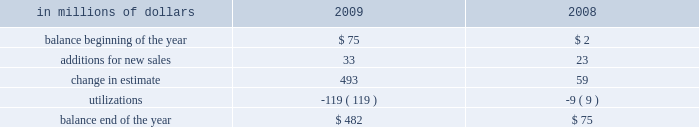Citigroup 2019s repurchases are primarily from government sponsored entities .
The specific representations and warranties made by the company depend on the nature of the transaction and the requirements of the buyer .
Market conditions and credit-ratings agency requirements may also affect representations and warranties and the other provisions the company may agree to in loan sales .
In the event of a breach of the representations and warranties , the company may be required to either repurchase the mortgage loans ( generally at unpaid principal balance plus accrued interest ) with the identified defects or indemnify ( 201cmake-whole 201d ) the investor or insurer .
The company has recorded a repurchase reserve that is included in other liabilities in the consolidated balance sheet .
In the case of a repurchase , the company will bear any subsequent credit loss on the mortgage loans .
The company 2019s representations and warranties are generally not subject to stated limits in amount or time of coverage .
However , contractual liability arises only when the representations and warranties are breached and generally only when a loss results from the breach .
In the case of a repurchase , the loan is typically considered a credit- impaired loan and accounted for under sop 03-3 , 201caccounting for certain loans and debt securities , acquired in a transfer 201d ( now incorporated into asc 310-30 , receivables 2014loans and debt securities acquired with deteriorated credit quality ) .
These repurchases have not had a material impact on nonperforming loan statistics , because credit-impaired purchased sop 03-3 loans are not included in nonaccrual loans .
The company estimates its exposure to losses from its obligation to repurchase previously sold loans based on the probability of repurchase or make-whole and an estimated loss given repurchase or make-whole .
This estimate is calculated separately by sales vintage ( i.e. , the year the loans were sold ) based on a combination of historical trends and forecasted repurchases and losses considering the : ( 1 ) trends in requests by investors for loan documentation packages to be reviewed ; ( 2 ) trends in recent repurchases and make-wholes ; ( 3 ) historical percentage of claims made as a percentage of loan documentation package requests ; ( 4 ) success rate in appealing claims ; ( 5 ) inventory of unresolved claims ; and ( 6 ) estimated loss given repurchase or make-whole , including the loss of principal , accrued interest , and foreclosure costs .
The company does not change its estimation methodology by counterparty , but the historical experience and trends are considered when evaluating the overall reserve .
The request for loan documentation packages is an early indicator of a potential claim .
During 2009 , loan documentation package requests and the level of outstanding claims increased .
In addition , our loss severity estimates increased during 2009 due to the impact of macroeconomic factors and recent experience .
These factors contributed to a $ 493 million change in estimate for this reserve in 2009 .
As indicated above , the repurchase reserve is calculated by sales vintage .
The majority of the repurchases in 2009 were from the 2006 and 2007 sales vintages , which also represent the vintages with the largest loss- given-repurchase .
An insignificant percentage of 2009 repurchases were from vintages prior to 2006 , and this is expected to decrease , because those vintages are later in the credit cycle .
Although early in the credit cycle , the company has experienced improved repurchase and loss-given-repurchase statistics from the 2008 and 2009 vintages .
In the case of a repurchase of a credit-impaired sop 03-3 loan ( now incorporated into asc 310-30 ) , the difference between the loan 2019s fair value and unpaid principal balance at the time of the repurchase is recorded as a utilization of the repurchase reserve .
Payments to make the investor whole are also treated as utilizations and charged directly against the reserve .
The provision for estimated probable losses arising from loan sales is recorded as an adjustment to the gain on sale , which is included in other revenue in the consolidated statement of income .
A liability for representations and warranties is estimated when the company sells loans and is updated quarterly .
Any subsequent adjustment to the provision is recorded in other revenue in the consolidated statement of income .
The activity in the repurchase reserve for the years ended december 31 , 2009 and 2008 is as follows: .
Goodwill goodwill represents an acquired company 2019s acquisition cost over the fair value of net tangible and intangible assets acquired .
Goodwill is subject to annual impairment tests , whereby goodwill is allocated to the company 2019s reporting units and an impairment is deemed to exist if the carrying value of a reporting unit exceeds its estimated fair value .
Furthermore , on any business dispositions , goodwill is allocated to the business disposed of based on the ratio of the fair value of the business disposed of to the fair value of the reporting unit .
Intangible assets intangible assets 2014including core deposit intangibles , present value of future profits , purchased credit card relationships , other customer relationships , and other intangible assets , but excluding msrs 2014are amortized over their estimated useful lives .
Intangible assets deemed to have indefinite useful lives , primarily certain asset management contracts and trade names , are not amortized and are subject to annual impairment tests .
An impairment exists if the carrying value of the indefinite-lived intangible asset exceeds its fair value .
For other intangible assets subject to amortization , an impairment is recognized if the carrying amount is not recoverable and exceeds the fair value of the intangible asset .
Other assets and other liabilities other assets include , among other items , loans held-for-sale , deferred tax assets , equity-method investments , interest and fees receivable , premises and equipment , end-user derivatives in a net receivable position , repossessed assets , and other receivables. .
What was the net change in the repurchase reserve between 2008 and 2009 , in millions? 
Computations: (482 - 75)
Answer: 407.0. Citigroup 2019s repurchases are primarily from government sponsored entities .
The specific representations and warranties made by the company depend on the nature of the transaction and the requirements of the buyer .
Market conditions and credit-ratings agency requirements may also affect representations and warranties and the other provisions the company may agree to in loan sales .
In the event of a breach of the representations and warranties , the company may be required to either repurchase the mortgage loans ( generally at unpaid principal balance plus accrued interest ) with the identified defects or indemnify ( 201cmake-whole 201d ) the investor or insurer .
The company has recorded a repurchase reserve that is included in other liabilities in the consolidated balance sheet .
In the case of a repurchase , the company will bear any subsequent credit loss on the mortgage loans .
The company 2019s representations and warranties are generally not subject to stated limits in amount or time of coverage .
However , contractual liability arises only when the representations and warranties are breached and generally only when a loss results from the breach .
In the case of a repurchase , the loan is typically considered a credit- impaired loan and accounted for under sop 03-3 , 201caccounting for certain loans and debt securities , acquired in a transfer 201d ( now incorporated into asc 310-30 , receivables 2014loans and debt securities acquired with deteriorated credit quality ) .
These repurchases have not had a material impact on nonperforming loan statistics , because credit-impaired purchased sop 03-3 loans are not included in nonaccrual loans .
The company estimates its exposure to losses from its obligation to repurchase previously sold loans based on the probability of repurchase or make-whole and an estimated loss given repurchase or make-whole .
This estimate is calculated separately by sales vintage ( i.e. , the year the loans were sold ) based on a combination of historical trends and forecasted repurchases and losses considering the : ( 1 ) trends in requests by investors for loan documentation packages to be reviewed ; ( 2 ) trends in recent repurchases and make-wholes ; ( 3 ) historical percentage of claims made as a percentage of loan documentation package requests ; ( 4 ) success rate in appealing claims ; ( 5 ) inventory of unresolved claims ; and ( 6 ) estimated loss given repurchase or make-whole , including the loss of principal , accrued interest , and foreclosure costs .
The company does not change its estimation methodology by counterparty , but the historical experience and trends are considered when evaluating the overall reserve .
The request for loan documentation packages is an early indicator of a potential claim .
During 2009 , loan documentation package requests and the level of outstanding claims increased .
In addition , our loss severity estimates increased during 2009 due to the impact of macroeconomic factors and recent experience .
These factors contributed to a $ 493 million change in estimate for this reserve in 2009 .
As indicated above , the repurchase reserve is calculated by sales vintage .
The majority of the repurchases in 2009 were from the 2006 and 2007 sales vintages , which also represent the vintages with the largest loss- given-repurchase .
An insignificant percentage of 2009 repurchases were from vintages prior to 2006 , and this is expected to decrease , because those vintages are later in the credit cycle .
Although early in the credit cycle , the company has experienced improved repurchase and loss-given-repurchase statistics from the 2008 and 2009 vintages .
In the case of a repurchase of a credit-impaired sop 03-3 loan ( now incorporated into asc 310-30 ) , the difference between the loan 2019s fair value and unpaid principal balance at the time of the repurchase is recorded as a utilization of the repurchase reserve .
Payments to make the investor whole are also treated as utilizations and charged directly against the reserve .
The provision for estimated probable losses arising from loan sales is recorded as an adjustment to the gain on sale , which is included in other revenue in the consolidated statement of income .
A liability for representations and warranties is estimated when the company sells loans and is updated quarterly .
Any subsequent adjustment to the provision is recorded in other revenue in the consolidated statement of income .
The activity in the repurchase reserve for the years ended december 31 , 2009 and 2008 is as follows: .
Goodwill goodwill represents an acquired company 2019s acquisition cost over the fair value of net tangible and intangible assets acquired .
Goodwill is subject to annual impairment tests , whereby goodwill is allocated to the company 2019s reporting units and an impairment is deemed to exist if the carrying value of a reporting unit exceeds its estimated fair value .
Furthermore , on any business dispositions , goodwill is allocated to the business disposed of based on the ratio of the fair value of the business disposed of to the fair value of the reporting unit .
Intangible assets intangible assets 2014including core deposit intangibles , present value of future profits , purchased credit card relationships , other customer relationships , and other intangible assets , but excluding msrs 2014are amortized over their estimated useful lives .
Intangible assets deemed to have indefinite useful lives , primarily certain asset management contracts and trade names , are not amortized and are subject to annual impairment tests .
An impairment exists if the carrying value of the indefinite-lived intangible asset exceeds its fair value .
For other intangible assets subject to amortization , an impairment is recognized if the carrying amount is not recoverable and exceeds the fair value of the intangible asset .
Other assets and other liabilities other assets include , among other items , loans held-for-sale , deferred tax assets , equity-method investments , interest and fees receivable , premises and equipment , end-user derivatives in a net receivable position , repossessed assets , and other receivables. .
What was the ratio of the change in estimate for 2009 to 2008? 
Rationale: the ratio of the the change in estimate reserve was $ 8.35 to $ 1 for 2009 compared to 2008
Computations: (493 / 59)
Answer: 8.35593. Citigroup 2019s repurchases are primarily from government sponsored entities .
The specific representations and warranties made by the company depend on the nature of the transaction and the requirements of the buyer .
Market conditions and credit-ratings agency requirements may also affect representations and warranties and the other provisions the company may agree to in loan sales .
In the event of a breach of the representations and warranties , the company may be required to either repurchase the mortgage loans ( generally at unpaid principal balance plus accrued interest ) with the identified defects or indemnify ( 201cmake-whole 201d ) the investor or insurer .
The company has recorded a repurchase reserve that is included in other liabilities in the consolidated balance sheet .
In the case of a repurchase , the company will bear any subsequent credit loss on the mortgage loans .
The company 2019s representations and warranties are generally not subject to stated limits in amount or time of coverage .
However , contractual liability arises only when the representations and warranties are breached and generally only when a loss results from the breach .
In the case of a repurchase , the loan is typically considered a credit- impaired loan and accounted for under sop 03-3 , 201caccounting for certain loans and debt securities , acquired in a transfer 201d ( now incorporated into asc 310-30 , receivables 2014loans and debt securities acquired with deteriorated credit quality ) .
These repurchases have not had a material impact on nonperforming loan statistics , because credit-impaired purchased sop 03-3 loans are not included in nonaccrual loans .
The company estimates its exposure to losses from its obligation to repurchase previously sold loans based on the probability of repurchase or make-whole and an estimated loss given repurchase or make-whole .
This estimate is calculated separately by sales vintage ( i.e. , the year the loans were sold ) based on a combination of historical trends and forecasted repurchases and losses considering the : ( 1 ) trends in requests by investors for loan documentation packages to be reviewed ; ( 2 ) trends in recent repurchases and make-wholes ; ( 3 ) historical percentage of claims made as a percentage of loan documentation package requests ; ( 4 ) success rate in appealing claims ; ( 5 ) inventory of unresolved claims ; and ( 6 ) estimated loss given repurchase or make-whole , including the loss of principal , accrued interest , and foreclosure costs .
The company does not change its estimation methodology by counterparty , but the historical experience and trends are considered when evaluating the overall reserve .
The request for loan documentation packages is an early indicator of a potential claim .
During 2009 , loan documentation package requests and the level of outstanding claims increased .
In addition , our loss severity estimates increased during 2009 due to the impact of macroeconomic factors and recent experience .
These factors contributed to a $ 493 million change in estimate for this reserve in 2009 .
As indicated above , the repurchase reserve is calculated by sales vintage .
The majority of the repurchases in 2009 were from the 2006 and 2007 sales vintages , which also represent the vintages with the largest loss- given-repurchase .
An insignificant percentage of 2009 repurchases were from vintages prior to 2006 , and this is expected to decrease , because those vintages are later in the credit cycle .
Although early in the credit cycle , the company has experienced improved repurchase and loss-given-repurchase statistics from the 2008 and 2009 vintages .
In the case of a repurchase of a credit-impaired sop 03-3 loan ( now incorporated into asc 310-30 ) , the difference between the loan 2019s fair value and unpaid principal balance at the time of the repurchase is recorded as a utilization of the repurchase reserve .
Payments to make the investor whole are also treated as utilizations and charged directly against the reserve .
The provision for estimated probable losses arising from loan sales is recorded as an adjustment to the gain on sale , which is included in other revenue in the consolidated statement of income .
A liability for representations and warranties is estimated when the company sells loans and is updated quarterly .
Any subsequent adjustment to the provision is recorded in other revenue in the consolidated statement of income .
The activity in the repurchase reserve for the years ended december 31 , 2009 and 2008 is as follows: .
Goodwill goodwill represents an acquired company 2019s acquisition cost over the fair value of net tangible and intangible assets acquired .
Goodwill is subject to annual impairment tests , whereby goodwill is allocated to the company 2019s reporting units and an impairment is deemed to exist if the carrying value of a reporting unit exceeds its estimated fair value .
Furthermore , on any business dispositions , goodwill is allocated to the business disposed of based on the ratio of the fair value of the business disposed of to the fair value of the reporting unit .
Intangible assets intangible assets 2014including core deposit intangibles , present value of future profits , purchased credit card relationships , other customer relationships , and other intangible assets , but excluding msrs 2014are amortized over their estimated useful lives .
Intangible assets deemed to have indefinite useful lives , primarily certain asset management contracts and trade names , are not amortized and are subject to annual impairment tests .
An impairment exists if the carrying value of the indefinite-lived intangible asset exceeds its fair value .
For other intangible assets subject to amortization , an impairment is recognized if the carrying amount is not recoverable and exceeds the fair value of the intangible asset .
Other assets and other liabilities other assets include , among other items , loans held-for-sale , deferred tax assets , equity-method investments , interest and fees receivable , premises and equipment , end-user derivatives in a net receivable position , repossessed assets , and other receivables. .
What was the percent of the increase the additions for new sales of the repurchase reserve from 2008 to 2009? 
Rationale: the additions for new sales of the repurchase reserve increased by 43.5% from 2008 to 2009
Computations: ((33 - 23) / 23)
Answer: 0.43478. 